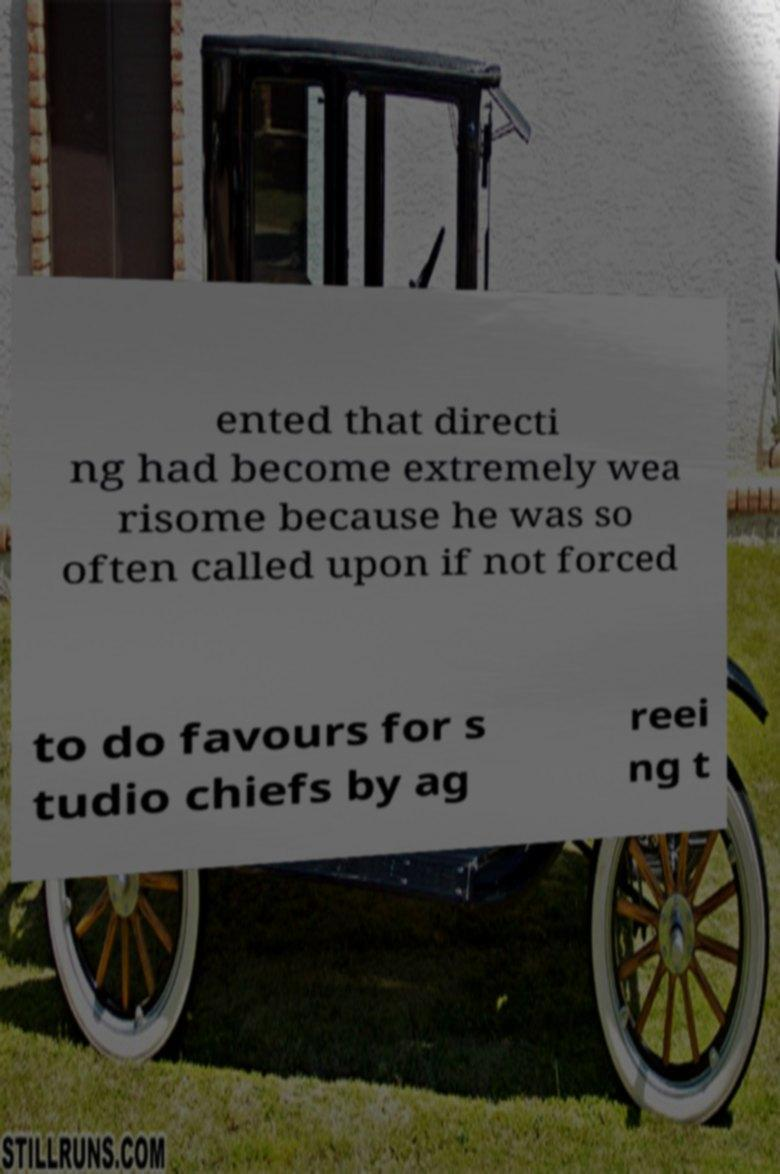Could you extract and type out the text from this image? ented that directi ng had become extremely wea risome because he was so often called upon if not forced to do favours for s tudio chiefs by ag reei ng t 